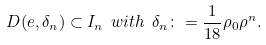Convert formula to latex. <formula><loc_0><loc_0><loc_500><loc_500>D ( e , \delta _ { n } ) \subset I _ { n } \ w i t h \ \delta _ { n } \colon = \frac { 1 } { 1 8 } \rho _ { 0 } \rho ^ { n } .</formula> 